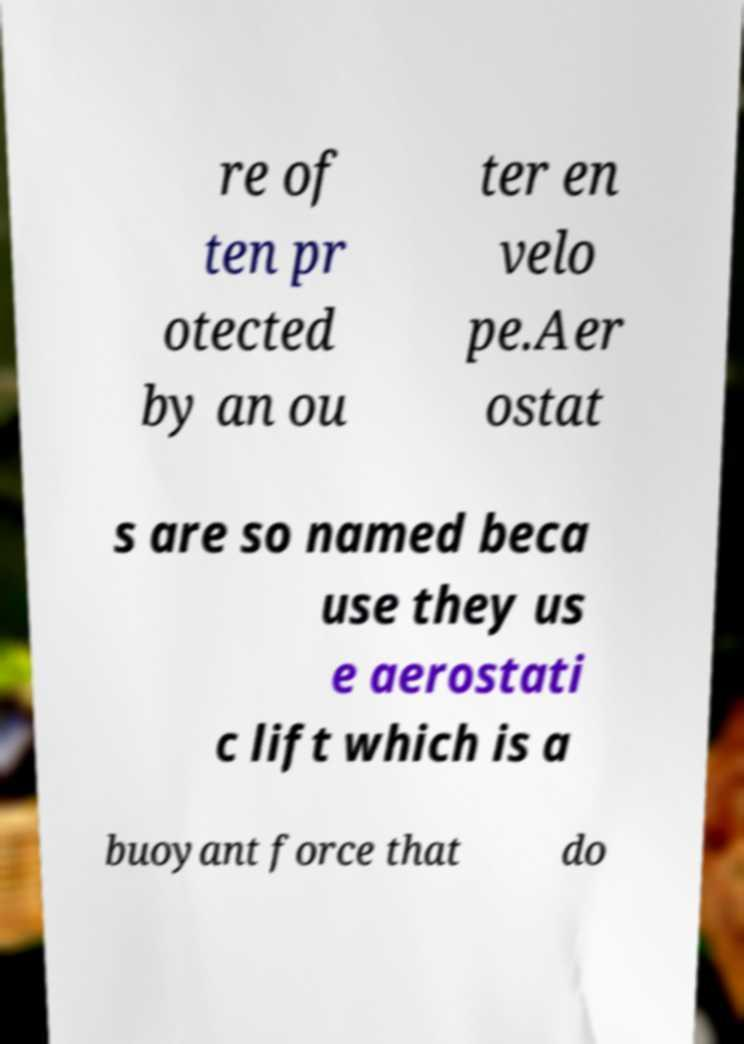Please read and relay the text visible in this image. What does it say? re of ten pr otected by an ou ter en velo pe.Aer ostat s are so named beca use they us e aerostati c lift which is a buoyant force that do 